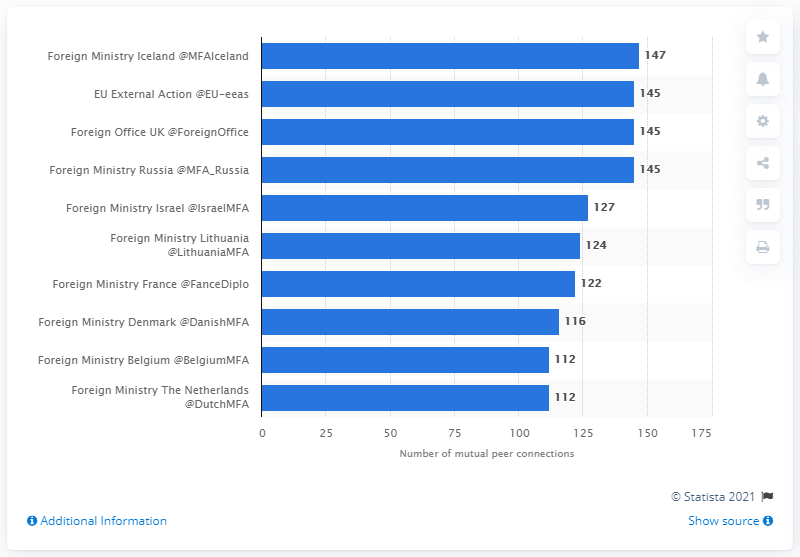List a handful of essential elements in this visual. The Icelandic Foreign Ministry followed 147 foreign ministries on Twitter. The EU External Action Service had 145 Twitter connections as of [date]. 